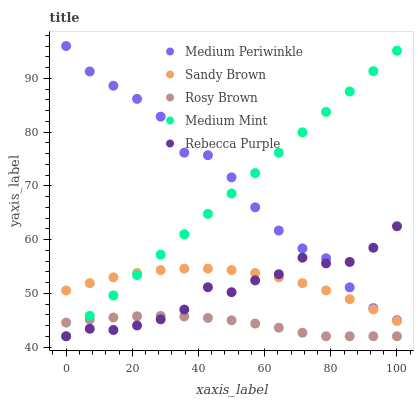Does Rosy Brown have the minimum area under the curve?
Answer yes or no. Yes. Does Medium Periwinkle have the maximum area under the curve?
Answer yes or no. Yes. Does Sandy Brown have the minimum area under the curve?
Answer yes or no. No. Does Sandy Brown have the maximum area under the curve?
Answer yes or no. No. Is Medium Mint the smoothest?
Answer yes or no. Yes. Is Medium Periwinkle the roughest?
Answer yes or no. Yes. Is Sandy Brown the smoothest?
Answer yes or no. No. Is Sandy Brown the roughest?
Answer yes or no. No. Does Medium Mint have the lowest value?
Answer yes or no. Yes. Does Sandy Brown have the lowest value?
Answer yes or no. No. Does Medium Periwinkle have the highest value?
Answer yes or no. Yes. Does Sandy Brown have the highest value?
Answer yes or no. No. Is Rosy Brown less than Sandy Brown?
Answer yes or no. Yes. Is Sandy Brown greater than Rosy Brown?
Answer yes or no. Yes. Does Medium Mint intersect Rebecca Purple?
Answer yes or no. Yes. Is Medium Mint less than Rebecca Purple?
Answer yes or no. No. Is Medium Mint greater than Rebecca Purple?
Answer yes or no. No. Does Rosy Brown intersect Sandy Brown?
Answer yes or no. No. 